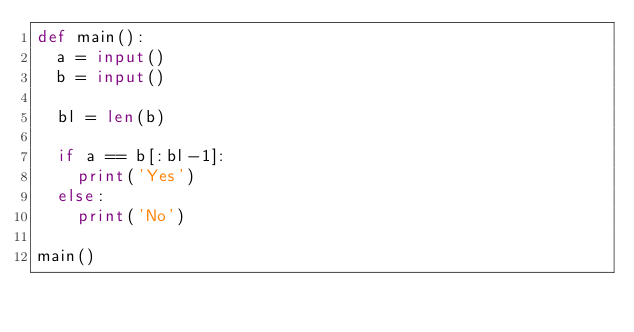Convert code to text. <code><loc_0><loc_0><loc_500><loc_500><_Python_>def main():
  a = input()
  b = input()
  
  bl = len(b)
  
  if a == b[:bl-1]:
    print('Yes')
  else:
    print('No')
  
main()</code> 